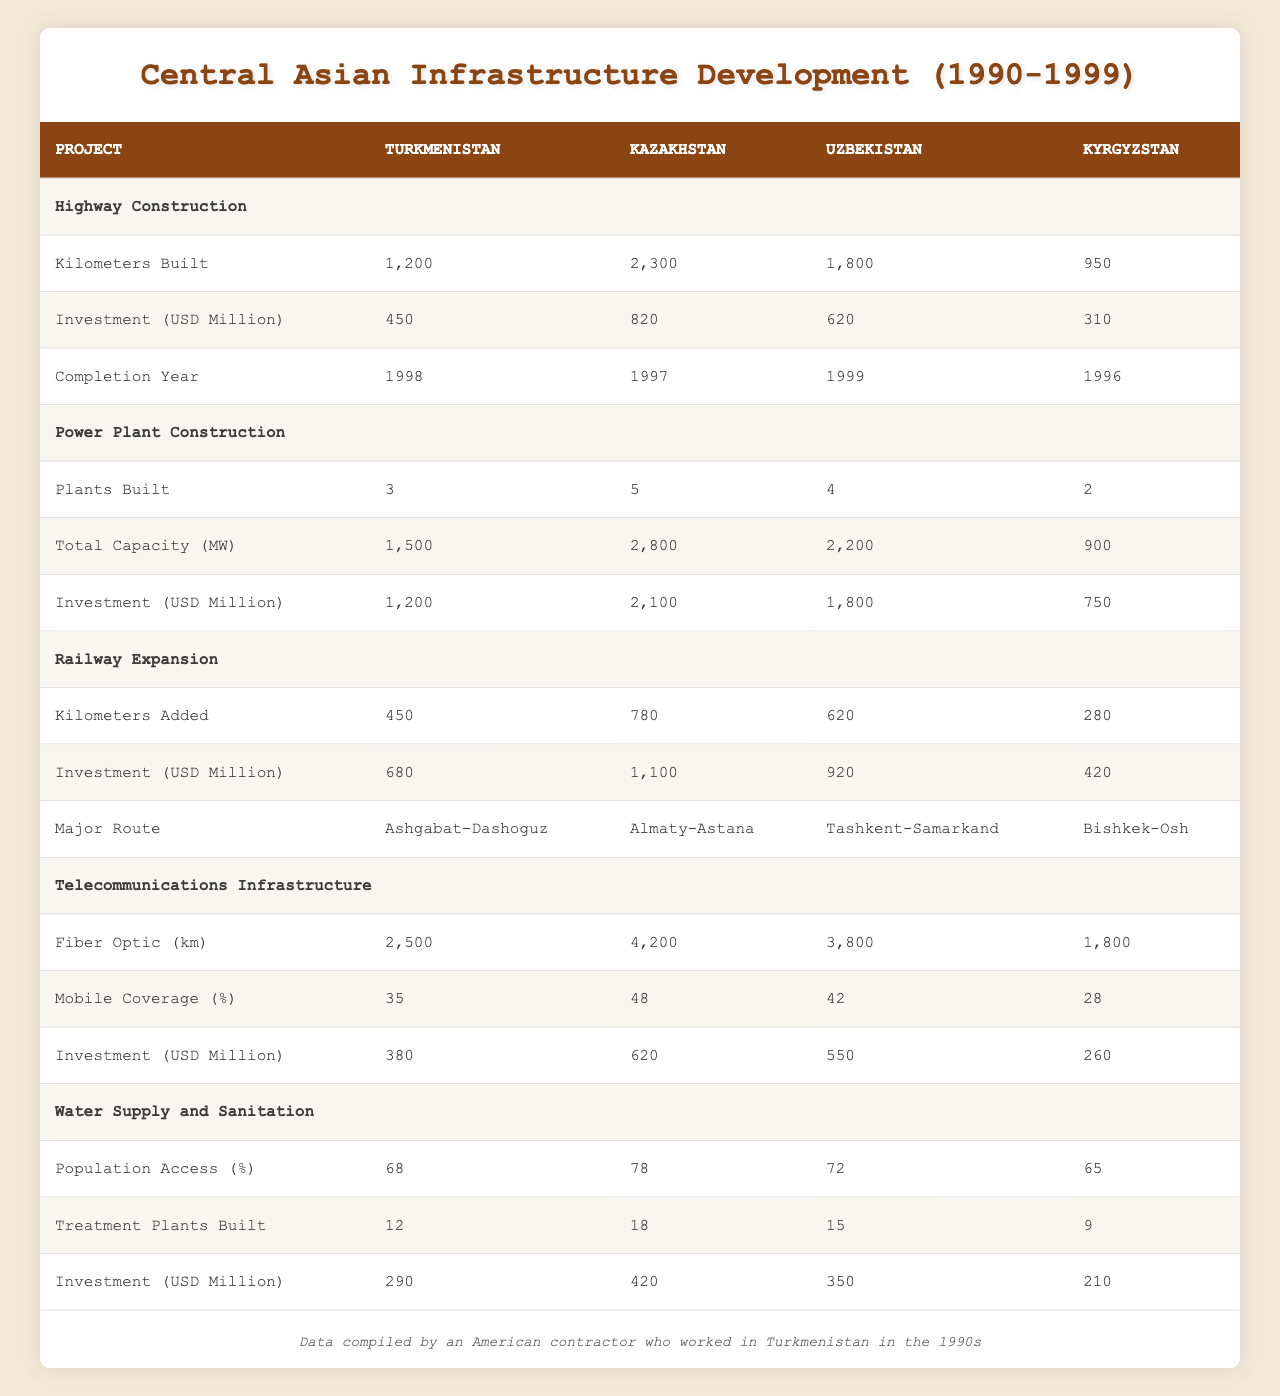What country had the highest investment in highway construction? To find the country with the highest investment in highway construction, we look at the investment amounts: Turkmenistan (450 million), Kazakhstan (820 million), Uzbekistan (620 million), and Kyrgyzstan (310 million). Kazakhstan has the highest amount at 820 million.
Answer: Kazakhstan How many kilometers of highways were built in Turkmenistan? The table shows that Turkmenistan built 1,200 kilometers of highways.
Answer: 1,200 kilometers What is the total number of power plants built in Kazakhstan and Uzbekistan combined? To find the total, add the power plants built: Kazakhstan (5) and Uzbekistan (4). The sum is 5 + 4 = 9.
Answer: 9 plants Did Kyrgyzstan have a higher percentage of mobile coverage than Turkmenistan? Kyrgyzstan's mobile coverage is 28%, while Turkmenistan's is 35%. Since 28% is less than 35%, the statement is false.
Answer: No What is the average investment in power plant construction across the four countries? To calculate the average, sum the investments: Turkmenistan (1200 million) + Kazakhstan (2100 million) + Uzbekistan (1800 million) + Kyrgyzstan (750 million) = 5850 million. Divide by the number of countries (4) to get the average: 5850 / 4 = 1462.5 million.
Answer: 1462.5 million Which country had the lowest population access to water supply and sanitation? The population access percentages are as follows: Turkmenistan (68%), Kazakhstan (78%), Uzbekistan (72%), and Kyrgyzstan (65%). Kyrgyzstan has the lowest access at 65%.
Answer: Kyrgyzstan How many kilometers of railway were added in Kazakhstan compared to Turkmenistan? The difference in kilometers of railway added is found by subtracting Turkmenistan's kilometers (450) from Kazakhstan's (780): 780 - 450 = 330 kilometers.
Answer: 330 kilometers In which year was the last highway project completed in Uzbekistan? From the table, Uzbekistan's highway construction was completed in 1999.
Answer: 1999 What is the capacity difference in megawatts between Kazakhstan's and Kyrgyzstan's power plants? Kazakhstan's total capacity is 2800 megawatts and Kyrgyzstan's is 900 megawatts. The difference is 2800 - 900 = 1900 megawatts.
Answer: 1900 megawatts 